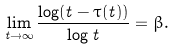Convert formula to latex. <formula><loc_0><loc_0><loc_500><loc_500>\lim _ { t \to \infty } \frac { \log ( t - \tau ( t ) ) } { \log t } = \beta .</formula> 